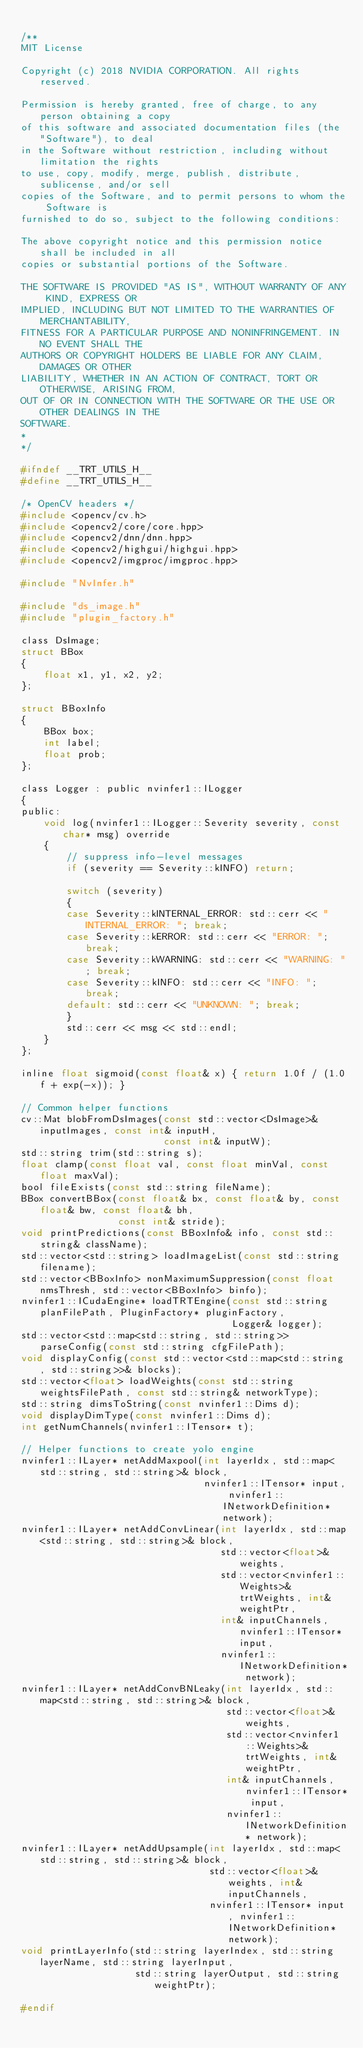<code> <loc_0><loc_0><loc_500><loc_500><_C_>
/**
MIT License

Copyright (c) 2018 NVIDIA CORPORATION. All rights reserved.

Permission is hereby granted, free of charge, to any person obtaining a copy
of this software and associated documentation files (the "Software"), to deal
in the Software without restriction, including without limitation the rights
to use, copy, modify, merge, publish, distribute, sublicense, and/or sell
copies of the Software, and to permit persons to whom the Software is
furnished to do so, subject to the following conditions:

The above copyright notice and this permission notice shall be included in all
copies or substantial portions of the Software.

THE SOFTWARE IS PROVIDED "AS IS", WITHOUT WARRANTY OF ANY KIND, EXPRESS OR
IMPLIED, INCLUDING BUT NOT LIMITED TO THE WARRANTIES OF MERCHANTABILITY,
FITNESS FOR A PARTICULAR PURPOSE AND NONINFRINGEMENT. IN NO EVENT SHALL THE
AUTHORS OR COPYRIGHT HOLDERS BE LIABLE FOR ANY CLAIM, DAMAGES OR OTHER
LIABILITY, WHETHER IN AN ACTION OF CONTRACT, TORT OR OTHERWISE, ARISING FROM,
OUT OF OR IN CONNECTION WITH THE SOFTWARE OR THE USE OR OTHER DEALINGS IN THE
SOFTWARE.
*
*/

#ifndef __TRT_UTILS_H__
#define __TRT_UTILS_H__

/* OpenCV headers */
#include <opencv/cv.h>
#include <opencv2/core/core.hpp>
#include <opencv2/dnn/dnn.hpp>
#include <opencv2/highgui/highgui.hpp>
#include <opencv2/imgproc/imgproc.hpp>

#include "NvInfer.h"

#include "ds_image.h"
#include "plugin_factory.h"

class DsImage;
struct BBox
{
    float x1, y1, x2, y2;
};

struct BBoxInfo
{
    BBox box;
    int label;
    float prob;
};

class Logger : public nvinfer1::ILogger
{
public:
    void log(nvinfer1::ILogger::Severity severity, const char* msg) override
    {
        // suppress info-level messages
        if (severity == Severity::kINFO) return;

        switch (severity)
        {
        case Severity::kINTERNAL_ERROR: std::cerr << "INTERNAL_ERROR: "; break;
        case Severity::kERROR: std::cerr << "ERROR: "; break;
        case Severity::kWARNING: std::cerr << "WARNING: "; break;
        case Severity::kINFO: std::cerr << "INFO: "; break;
        default: std::cerr << "UNKNOWN: "; break;
        }
        std::cerr << msg << std::endl;
    }
};

inline float sigmoid(const float& x) { return 1.0f / (1.0f + exp(-x)); }

// Common helper functions
cv::Mat blobFromDsImages(const std::vector<DsImage>& inputImages, const int& inputH,
                         const int& inputW);
std::string trim(std::string s);
float clamp(const float val, const float minVal, const float maxVal);
bool fileExists(const std::string fileName);
BBox convertBBox(const float& bx, const float& by, const float& bw, const float& bh,
                 const int& stride);
void printPredictions(const BBoxInfo& info, const std::string& className);
std::vector<std::string> loadImageList(const std::string filename);
std::vector<BBoxInfo> nonMaximumSuppression(const float nmsThresh, std::vector<BBoxInfo> binfo);
nvinfer1::ICudaEngine* loadTRTEngine(const std::string planFilePath, PluginFactory* pluginFactory,
                                     Logger& logger);
std::vector<std::map<std::string, std::string>> parseConfig(const std::string cfgFilePath);
void displayConfig(const std::vector<std::map<std::string, std::string>>& blocks);
std::vector<float> loadWeights(const std::string weightsFilePath, const std::string& networkType);
std::string dimsToString(const nvinfer1::Dims d);
void displayDimType(const nvinfer1::Dims d);
int getNumChannels(nvinfer1::ITensor* t);

// Helper functions to create yolo engine
nvinfer1::ILayer* netAddMaxpool(int layerIdx, std::map<std::string, std::string>& block,
                                nvinfer1::ITensor* input, nvinfer1::INetworkDefinition* network);
nvinfer1::ILayer* netAddConvLinear(int layerIdx, std::map<std::string, std::string>& block,
                                   std::vector<float>& weights,
                                   std::vector<nvinfer1::Weights>& trtWeights, int& weightPtr,
                                   int& inputChannels, nvinfer1::ITensor* input,
                                   nvinfer1::INetworkDefinition* network);
nvinfer1::ILayer* netAddConvBNLeaky(int layerIdx, std::map<std::string, std::string>& block,
                                    std::vector<float>& weights,
                                    std::vector<nvinfer1::Weights>& trtWeights, int& weightPtr,
                                    int& inputChannels, nvinfer1::ITensor* input,
                                    nvinfer1::INetworkDefinition* network);
nvinfer1::ILayer* netAddUpsample(int layerIdx, std::map<std::string, std::string>& block,
                                 std::vector<float>& weights, int& inputChannels,
                                 nvinfer1::ITensor* input, nvinfer1::INetworkDefinition* network);
void printLayerInfo(std::string layerIndex, std::string layerName, std::string layerInput,
                    std::string layerOutput, std::string weightPtr);

#endif
</code> 